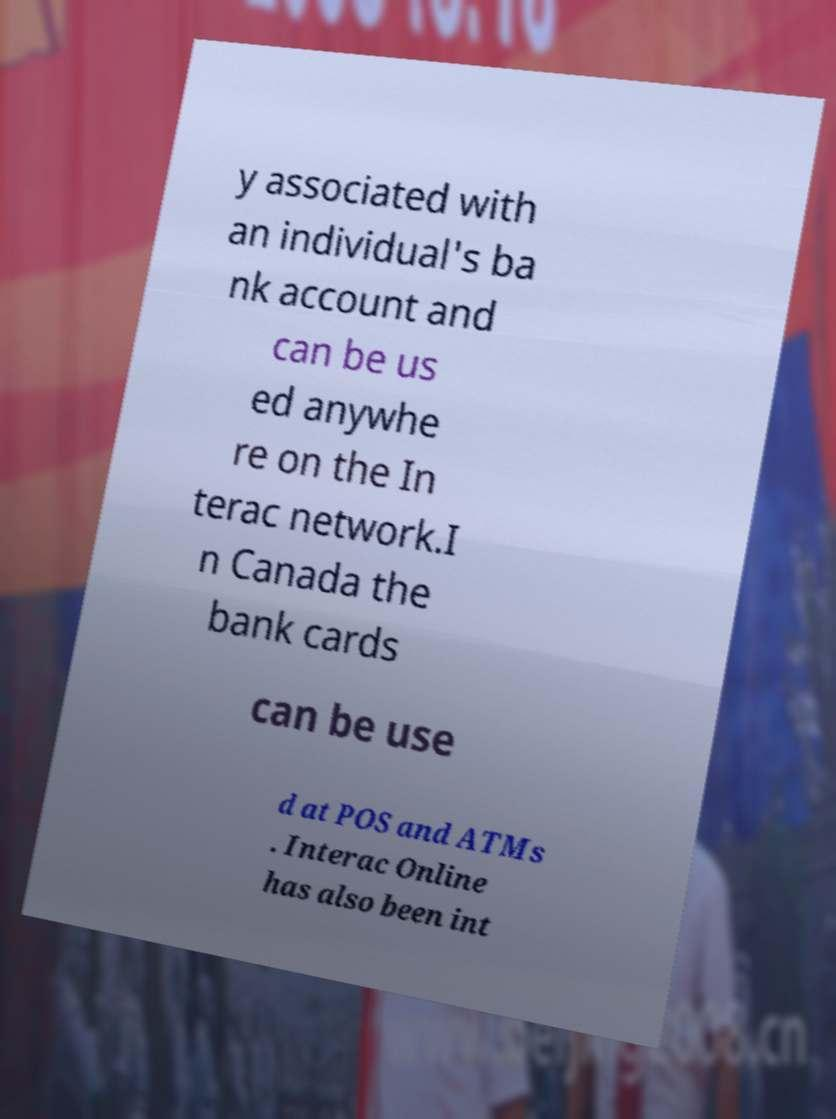For documentation purposes, I need the text within this image transcribed. Could you provide that? y associated with an individual's ba nk account and can be us ed anywhe re on the In terac network.I n Canada the bank cards can be use d at POS and ATMs . Interac Online has also been int 